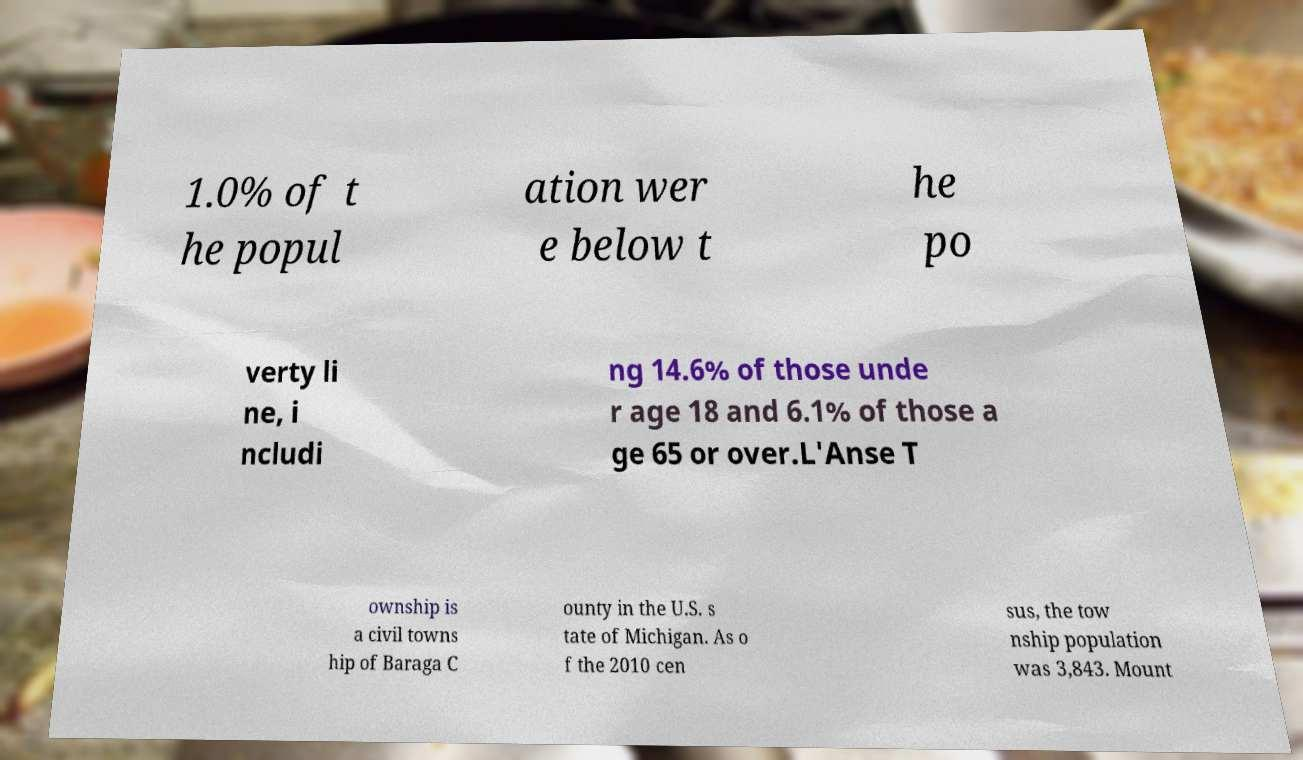Please identify and transcribe the text found in this image. 1.0% of t he popul ation wer e below t he po verty li ne, i ncludi ng 14.6% of those unde r age 18 and 6.1% of those a ge 65 or over.L'Anse T ownship is a civil towns hip of Baraga C ounty in the U.S. s tate of Michigan. As o f the 2010 cen sus, the tow nship population was 3,843. Mount 